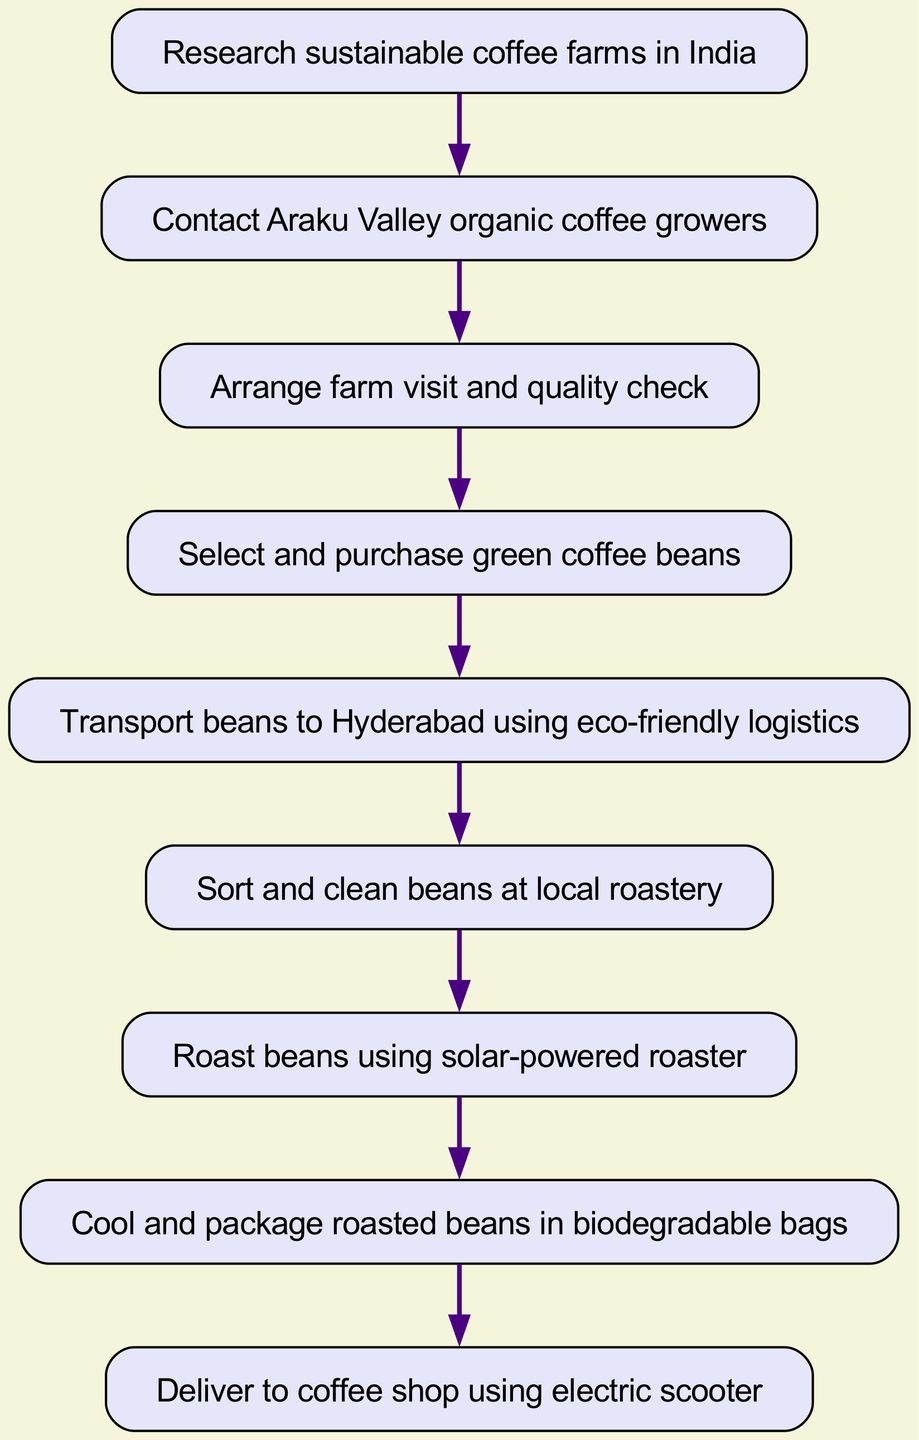What is the first step in the process? The first step in the process, as indicated by the starting node, is to "Research sustainable coffee farms in India."
Answer: Research sustainable coffee farms in India How many total steps are in the process? By counting all the individual nodes in the diagram, we see there are nine steps, from research to delivery.
Answer: Nine What is the last step of the process? The last step in the flow is to "Deliver to coffee shop using electric scooter," which is the final action.
Answer: Deliver to coffee shop using electric scooter Which step comes directly after selecting and purchasing green coffee beans? Following the selection and purchasing of green coffee beans, the next step is to "Transport beans to Hyderabad using eco-friendly logistics."
Answer: Transport beans to Hyderabad using eco-friendly logistics How many connections are there in total between steps? By examining the connections between nodes, we see that there are eight connections that show the flow from one step to the next throughout the process.
Answer: Eight What type of roaster is used in the roasting step? The diagram specifies that during the roasting step, a "solar-powered roaster" is utilized, indicating an eco-friendly choice.
Answer: Solar-powered roaster What action occurs before cooling and packaging the roasted beans? Before the action of cooling and packaging the roasted beans, the previous step is the roasting itself, specifically using the solar-powered method.
Answer: Roast beans using solar-powered roaster Which eco-friendly logistics method is used for transporting beans? The transportation of beans to Hyderabad uses "eco-friendly logistics," which ensures sustainability in the supply chain.
Answer: Eco-friendly logistics What is used for packaging the roasted beans? Upon completion of roasting, the roasted beans are packaged in "biodegradable bags," aligning with the sustainability focus of the process.
Answer: Biodegradable bags 